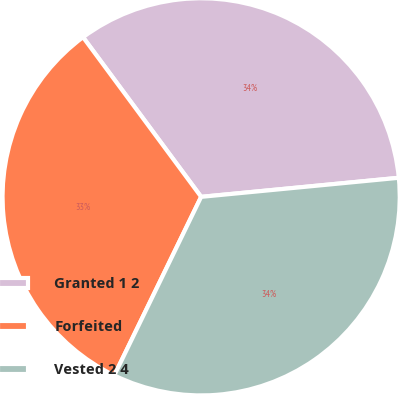<chart> <loc_0><loc_0><loc_500><loc_500><pie_chart><fcel>Granted 1 2<fcel>Forfeited<fcel>Vested 2 4<nl><fcel>33.61%<fcel>32.66%<fcel>33.74%<nl></chart> 